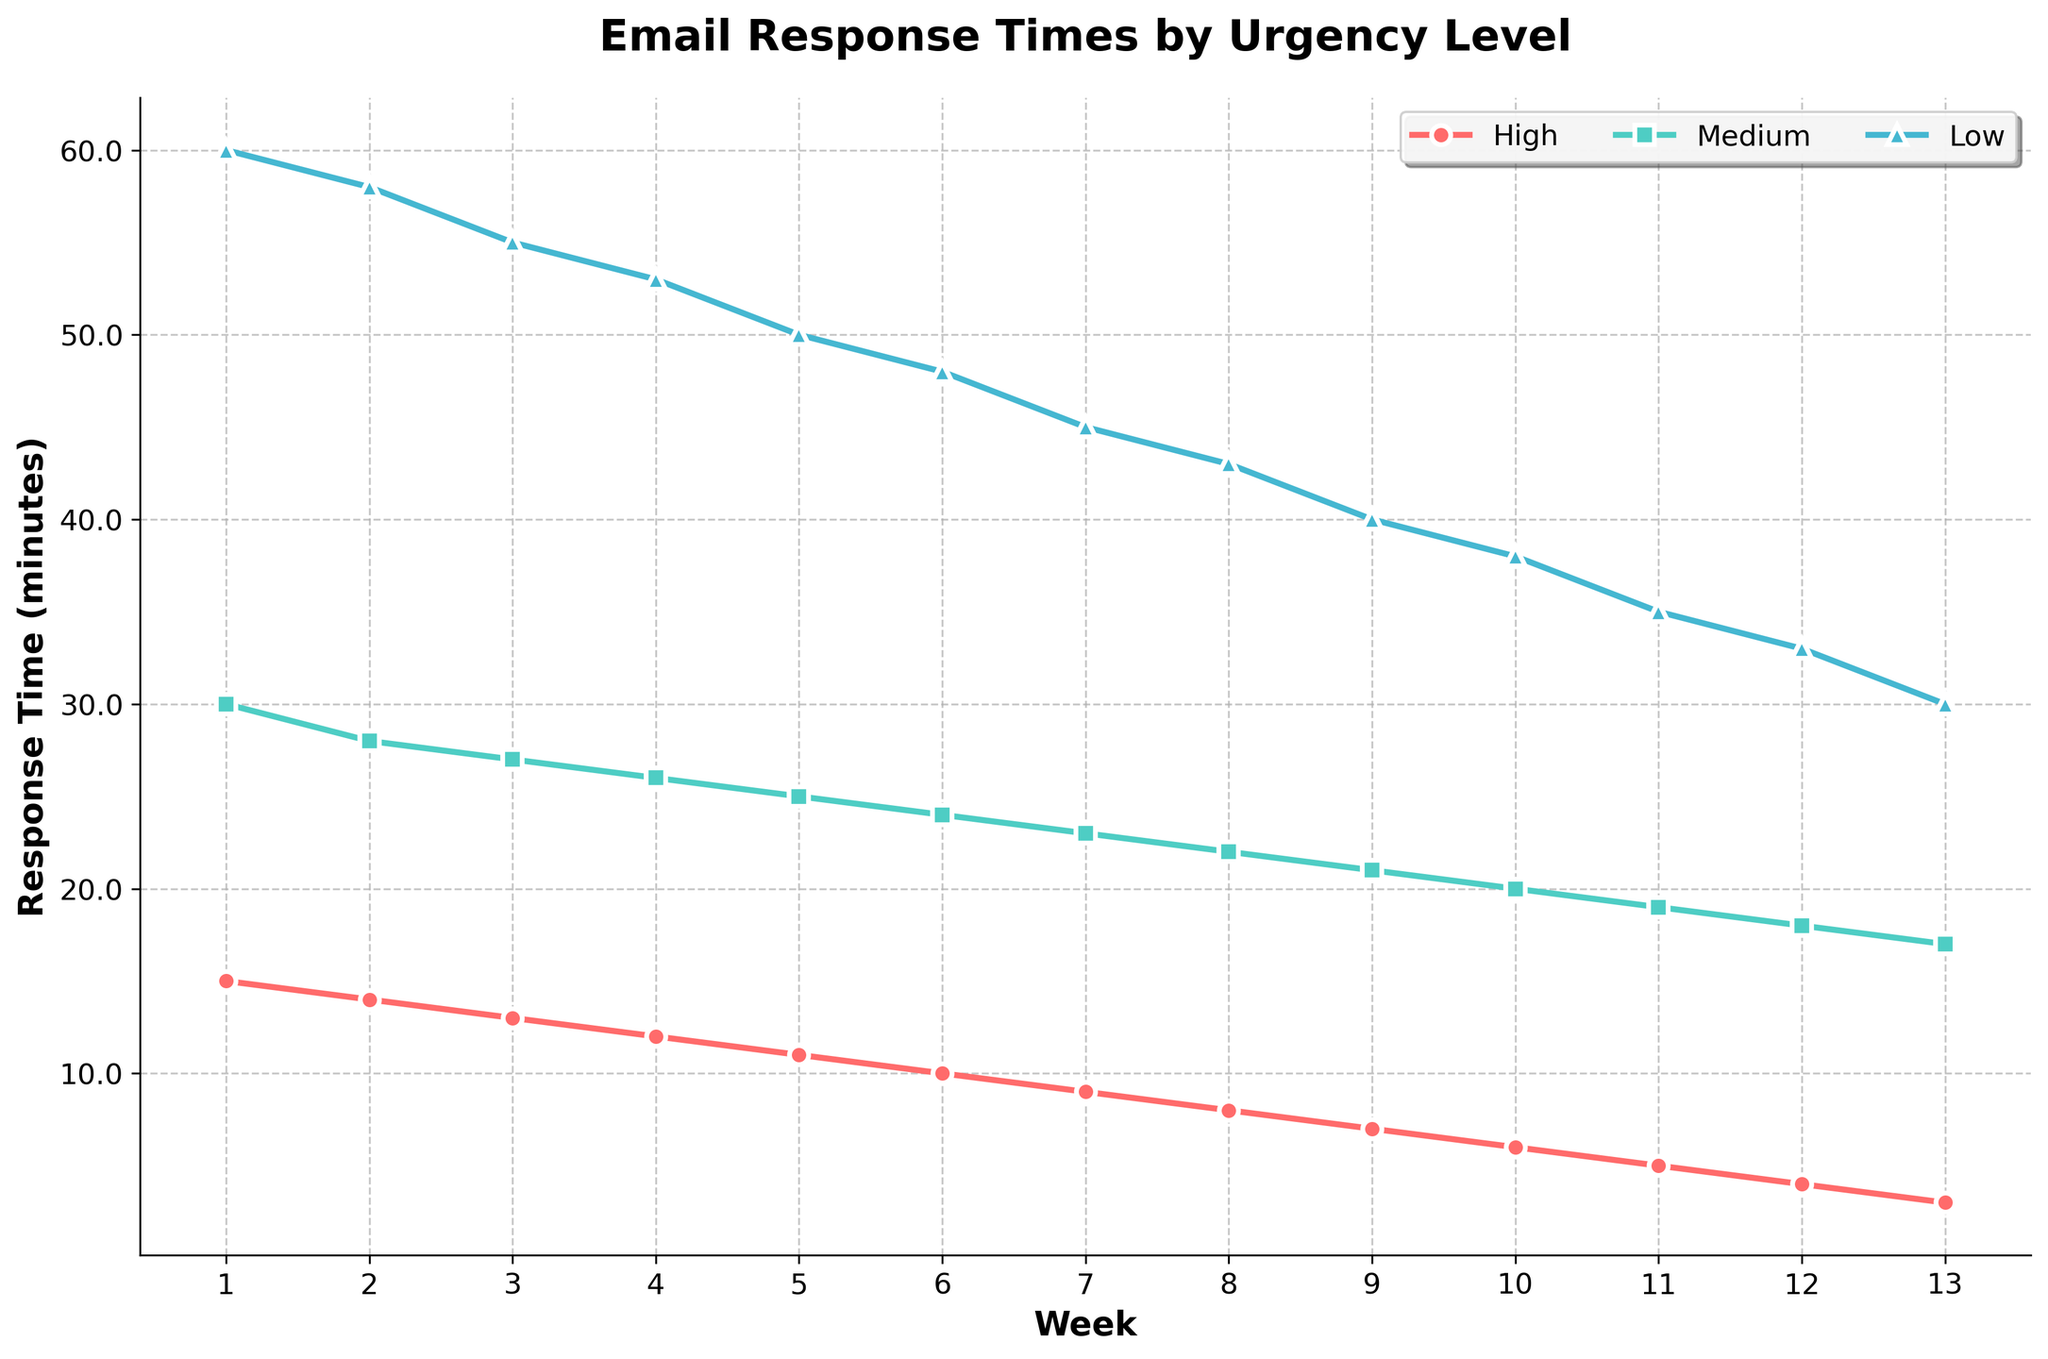What is the response time for high urgency emails in Week 7? To find the response time for high urgency emails in Week 7, locate the high urgency line in the plot, and trace it to Week 7 on the x-axis. The y-axis indicates the response time.
Answer: 9 minutes How does the response time for medium urgency emails in Week 10 compare with Week 5? The medium urgency line shows a response time of 20 minutes in Week 10 and 25 minutes in Week 5. Subtracting these gives 25 - 20.
Answer: 5 minutes less Which urgency level shows the steepest decline in response times over the quarter? By visually comparing the slopes of the lines, the high urgency line shows the steepest decline from 15 to 3 minutes over 13 weeks. Calculate the slope: (15 - 3) / 13.
Answer: High What is the average response time for low urgency emails across all weeks? Calculate the average by summing the response times for low urgency emails and dividing by the number of weeks: (60 + 58 + 55 + 53 + 50 + 48 + 45 + 43 + 40 + 38 + 35 + 33 + 30) / 13.
Answer: 45.7 minutes Which week shows the greatest difference between high and low urgency email response times? Calculate the differences for each week and compare. For Week 1, it's 60 - 15 = 45 minutes. For Week 2, it's 58 - 14 = 44 minutes. Continue for all weeks to find the maximum difference.
Answer: Week 1 What color is used to represent medium urgency emails? The plot uses green for medium urgency emails. Identify by following the medium urgency line and checking the legend.
Answer: Green How many weeks did it take for the response time of high urgency emails to drop below 10 minutes? Follow the high urgency line until it crosses below the 10-minute mark. This happens between Weeks 5 and 6.
Answer: 6 weeks From Week 4 to Week 8, by how much does the response time for medium urgency emails decrease? Find response times in Weeks 4 and 8 for medium urgency: 26 minutes and 22 minutes. Calculate the difference: 26 - 22.
Answer: 4 minutes What is the response time for low urgency emails in Week 12, and how does it compare to Week 6? The response time in Week 12 for low urgency is 33 minutes, and for Week 6 it is 48 minutes. Subtract these to find the difference: 48 - 33.
Answer: 15 minutes less Which urgency level consistently shows the highest response times every week? By looking at the plot, observe that the low urgency line remains the highest every week compared to the others.
Answer: Low 